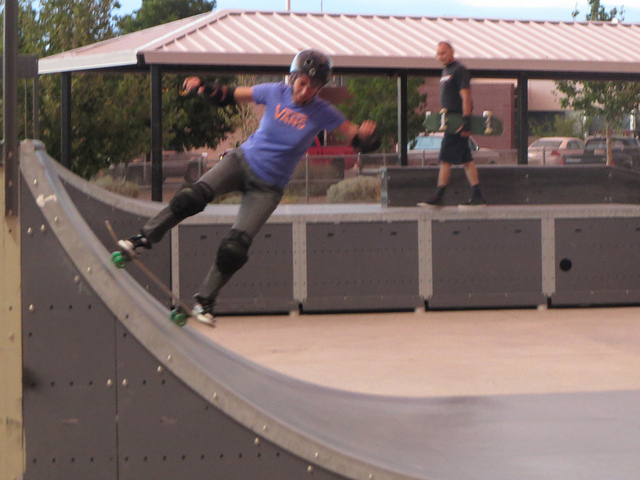Please provide a short description for this region: [0.18, 0.2, 0.6, 0.63]. A boy wearing a blue Vans t-shirt is skating on a ramp with great balance and skill. 